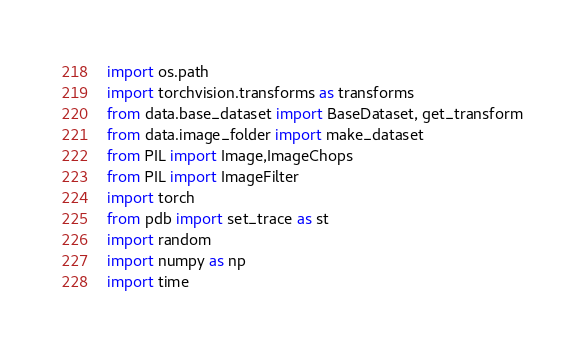Convert code to text. <code><loc_0><loc_0><loc_500><loc_500><_Python_>import os.path
import torchvision.transforms as transforms
from data.base_dataset import BaseDataset, get_transform
from data.image_folder import make_dataset
from PIL import Image,ImageChops
from PIL import ImageFilter
import torch
from pdb import set_trace as st
import random
import numpy as np
import time</code> 